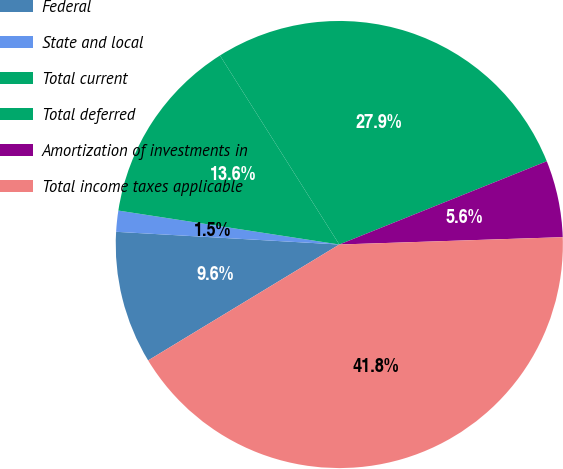Convert chart. <chart><loc_0><loc_0><loc_500><loc_500><pie_chart><fcel>Federal<fcel>State and local<fcel>Total current<fcel>Total deferred<fcel>Amortization of investments in<fcel>Total income taxes applicable<nl><fcel>9.58%<fcel>1.52%<fcel>13.61%<fcel>27.89%<fcel>5.55%<fcel>41.85%<nl></chart> 